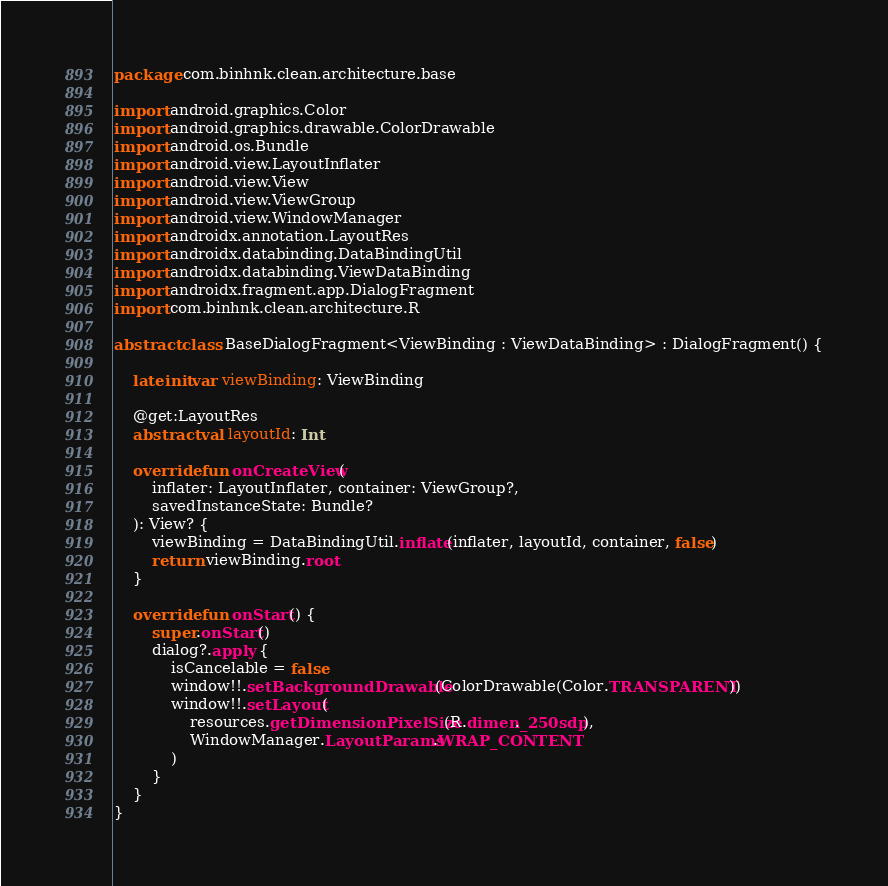Convert code to text. <code><loc_0><loc_0><loc_500><loc_500><_Kotlin_>package com.binhnk.clean.architecture.base

import android.graphics.Color
import android.graphics.drawable.ColorDrawable
import android.os.Bundle
import android.view.LayoutInflater
import android.view.View
import android.view.ViewGroup
import android.view.WindowManager
import androidx.annotation.LayoutRes
import androidx.databinding.DataBindingUtil
import androidx.databinding.ViewDataBinding
import androidx.fragment.app.DialogFragment
import com.binhnk.clean.architecture.R

abstract class BaseDialogFragment<ViewBinding : ViewDataBinding> : DialogFragment() {

    lateinit var viewBinding: ViewBinding

    @get:LayoutRes
    abstract val layoutId: Int

    override fun onCreateView(
        inflater: LayoutInflater, container: ViewGroup?,
        savedInstanceState: Bundle?
    ): View? {
        viewBinding = DataBindingUtil.inflate(inflater, layoutId, container, false)
        return viewBinding.root
    }

    override fun onStart() {
        super.onStart()
        dialog?.apply {
            isCancelable = false
            window!!.setBackgroundDrawable(ColorDrawable(Color.TRANSPARENT))
            window!!.setLayout(
                resources.getDimensionPixelSize(R.dimen._250sdp),
                WindowManager.LayoutParams.WRAP_CONTENT
            )
        }
    }
}</code> 